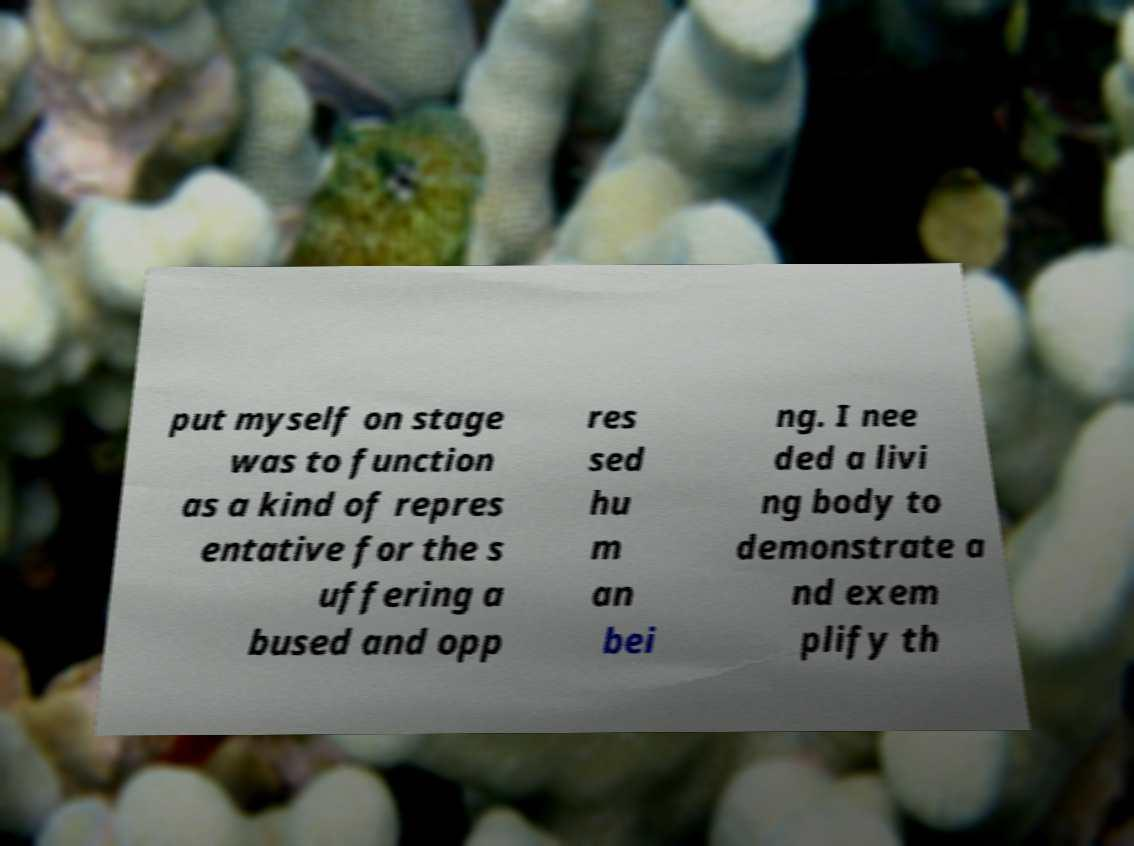What messages or text are displayed in this image? I need them in a readable, typed format. put myself on stage was to function as a kind of repres entative for the s uffering a bused and opp res sed hu m an bei ng. I nee ded a livi ng body to demonstrate a nd exem plify th 